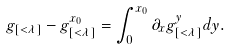Convert formula to latex. <formula><loc_0><loc_0><loc_500><loc_500>g _ { [ < \lambda ] } - g _ { [ < \lambda ] } ^ { x _ { 0 } } = \int _ { 0 } ^ { x _ { 0 } } \partial _ { x } g _ { [ < \lambda ] } ^ { y } d y .</formula> 